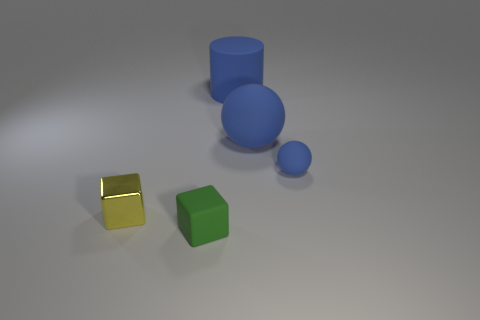How many objects are right of the metallic block and in front of the tiny matte ball?
Your answer should be compact. 1. How many big blue cubes are made of the same material as the tiny blue ball?
Your answer should be compact. 0. There is a block to the right of the tiny block that is behind the green matte block; what is its size?
Make the answer very short. Small. Is there another big purple shiny thing of the same shape as the metallic object?
Your answer should be very brief. No. There is a matte object that is to the left of the big blue rubber cylinder; is it the same size as the rubber ball that is behind the small blue thing?
Your answer should be very brief. No. Is the number of small yellow metallic blocks behind the big blue matte sphere less than the number of blue rubber cylinders that are left of the rubber block?
Offer a terse response. No. There is a big thing that is the same color as the cylinder; what material is it?
Ensure brevity in your answer.  Rubber. The matte thing that is on the left side of the large cylinder is what color?
Make the answer very short. Green. Is the color of the tiny rubber sphere the same as the tiny matte cube?
Offer a terse response. No. How many blue matte things are in front of the large matte object behind the blue ball to the left of the small blue rubber object?
Provide a succinct answer. 2. 